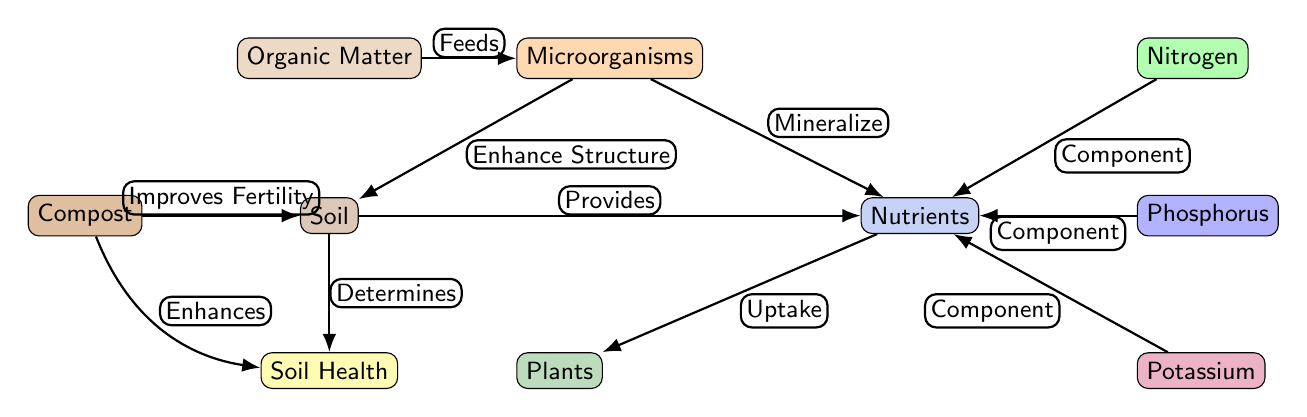What is the main component that feeds microorganisms? In the diagram, the arrow labeled "Feeds" connects "Organic Matter" to "Microorganisms," indicating that organic matter is the primary input that sustains microbial life in the soil.
Answer: Organic Matter How many types of nutrients are shown in the diagram? The diagram displays three types of nutrients connected to the "Nutrients" node: Nitrogen, Phosphorus, and Potassium, so by counting these nodes, we find there are three distinct nutrient types.
Answer: Three What does compost improve according to the diagram? The connection labeled "Improves Fertility" shows that compost contributes to or enhances the fertility of the soil, indicating its role in maintaining healthy soil conditions.
Answer: Fertility What does soil determine? The diagram indicates that the "Soil" node has an edge labeled "Determines" leading to "Soil Health," meaning that the condition or quality of the soil directly influences overall soil health.
Answer: Soil Health What is the relationship between soil and nutrients? The edge labeled "Provides" connects the "Soil" node to the "Nutrients" node, illustrating that the soil supplies essential nutrients needed for plant growth and development.
Answer: Provides How do microorganisms interact with nutrients? The arrow labeled "Mineralize" shows the interaction where microorganisms break down organic matter and release these nutrients into the soil, which are then available for plant uptake.
Answer: Mineralize Which component is related to nitrogen in the diagram? In the diagram, "Nitrogen" has a direct connection with "Nutrients," indicated by the edge labeled "Component," showing that nitrogen is a foundational element within the larger category of nutrients.
Answer: Component What enhances soil health according to the diagram? The diagram shows that "Compost" has an edge labeled "Enhances," connecting back to "Soil Health," suggesting that the addition of compost significantly contributes to the overall health of the soil.
Answer: Enhances Which node has the highest position in the diagram? The "Microorganisms" node appears positioned above the "Soil" node in the diagram, indicating that it is conceptually above or precedes the soil itself in the nutrient uptake process.
Answer: Microorganisms 